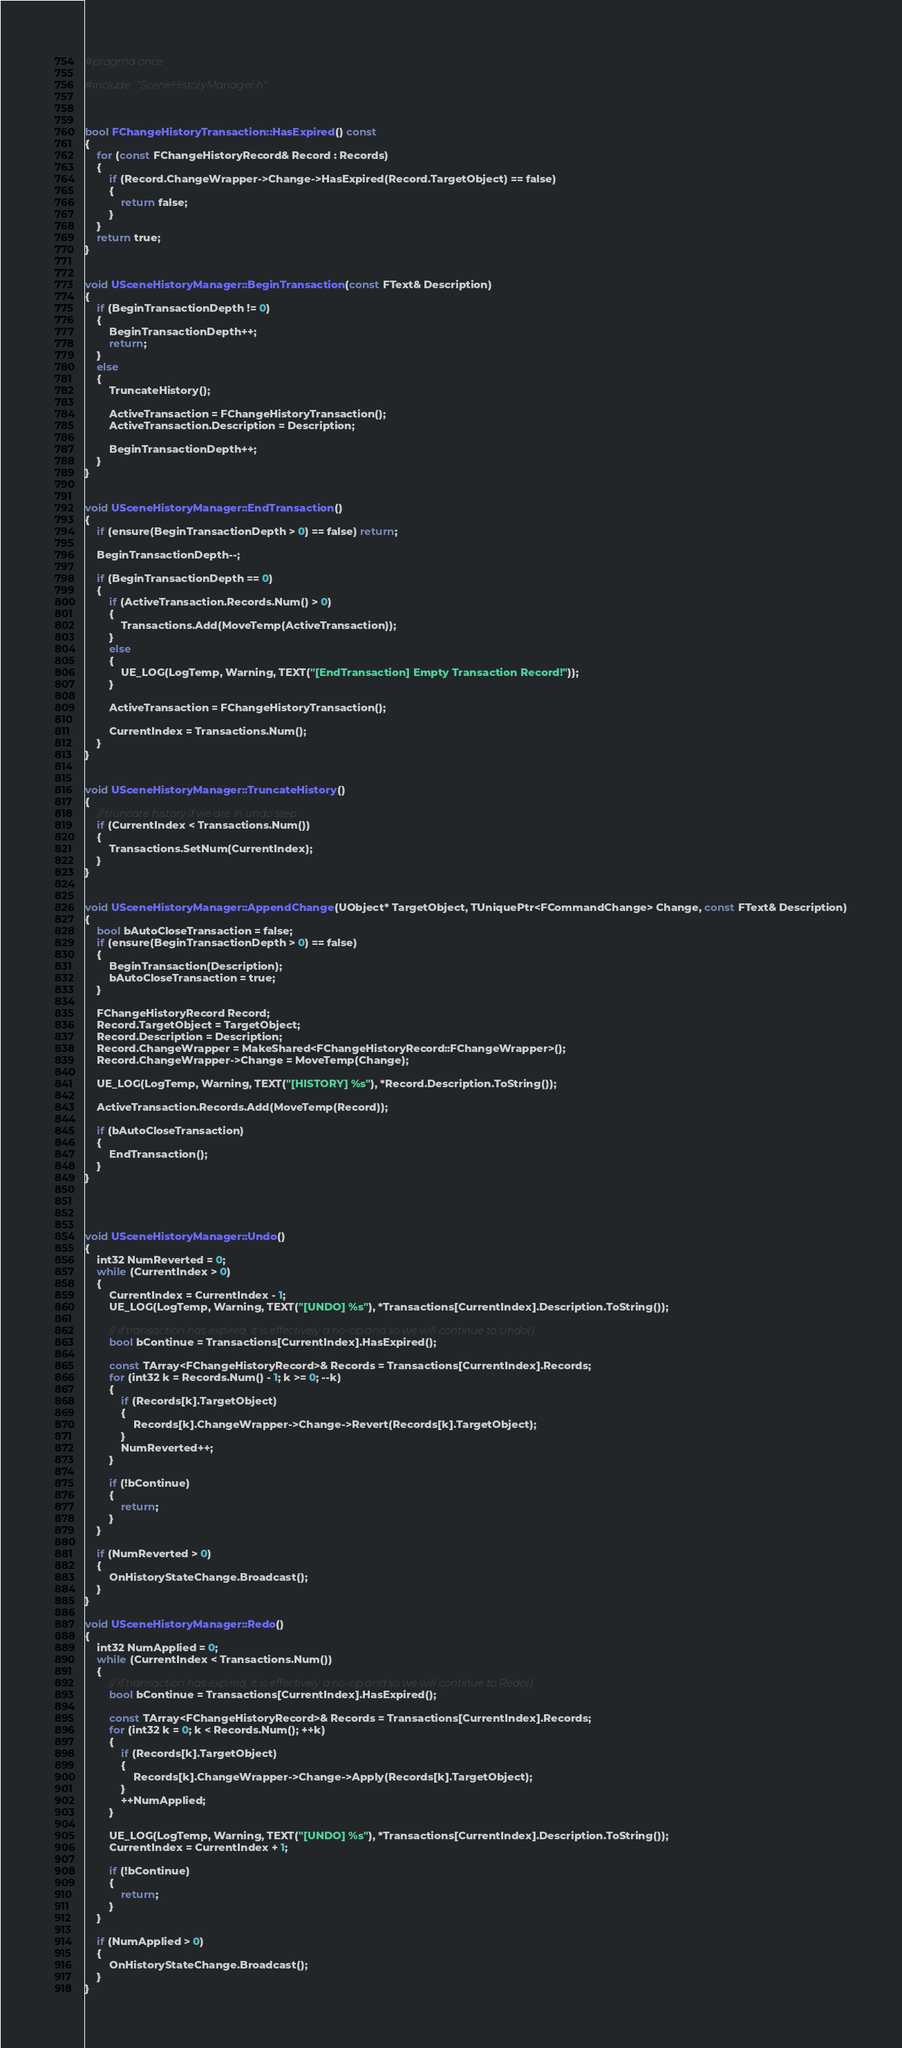Convert code to text. <code><loc_0><loc_0><loc_500><loc_500><_C++_>
#pragma once

#include "SceneHistoryManager.h"



bool FChangeHistoryTransaction::HasExpired() const
{
	for (const FChangeHistoryRecord& Record : Records)
	{
		if (Record.ChangeWrapper->Change->HasExpired(Record.TargetObject) == false)
		{
			return false;
		}
	}
	return true;
}


void USceneHistoryManager::BeginTransaction(const FText& Description)
{
	if (BeginTransactionDepth != 0)
	{
		BeginTransactionDepth++;
		return;
	}
	else
	{
		TruncateHistory();

		ActiveTransaction = FChangeHistoryTransaction();
		ActiveTransaction.Description = Description;

		BeginTransactionDepth++;
	}
}


void USceneHistoryManager::EndTransaction()
{
	if (ensure(BeginTransactionDepth > 0) == false) return;

	BeginTransactionDepth--;

	if (BeginTransactionDepth == 0)
	{
		if (ActiveTransaction.Records.Num() > 0)
		{
			Transactions.Add(MoveTemp(ActiveTransaction));
		}
		else
		{
			UE_LOG(LogTemp, Warning, TEXT("[EndTransaction] Empty Transaction Record!"));
		}

		ActiveTransaction = FChangeHistoryTransaction();

		CurrentIndex = Transactions.Num();
	}
}


void USceneHistoryManager::TruncateHistory()
{
	// truncate history if we are in undo step
	if (CurrentIndex < Transactions.Num())
	{
		Transactions.SetNum(CurrentIndex);
	}
}


void USceneHistoryManager::AppendChange(UObject* TargetObject, TUniquePtr<FCommandChange> Change, const FText& Description)
{
	bool bAutoCloseTransaction = false;
	if (ensure(BeginTransactionDepth > 0) == false)
	{
		BeginTransaction(Description);
		bAutoCloseTransaction = true;
	}

	FChangeHistoryRecord Record;
	Record.TargetObject = TargetObject;
	Record.Description = Description;
	Record.ChangeWrapper = MakeShared<FChangeHistoryRecord::FChangeWrapper>();
	Record.ChangeWrapper->Change = MoveTemp(Change);

	UE_LOG(LogTemp, Warning, TEXT("[HISTORY] %s"), *Record.Description.ToString());

	ActiveTransaction.Records.Add(MoveTemp(Record));

	if (bAutoCloseTransaction)
	{
		EndTransaction();
	}
}




void USceneHistoryManager::Undo()
{
	int32 NumReverted = 0;
	while (CurrentIndex > 0)
	{
		CurrentIndex = CurrentIndex - 1;
		UE_LOG(LogTemp, Warning, TEXT("[UNDO] %s"), *Transactions[CurrentIndex].Description.ToString());

		// if transaction has expired, it is effectively a no-op and so we will continue to Undo()
		bool bContinue = Transactions[CurrentIndex].HasExpired();

		const TArray<FChangeHistoryRecord>& Records = Transactions[CurrentIndex].Records;
		for (int32 k = Records.Num() - 1; k >= 0; --k)
		{
			if (Records[k].TargetObject)
			{
				Records[k].ChangeWrapper->Change->Revert(Records[k].TargetObject);
			}
			NumReverted++;
		}

		if (!bContinue)
		{
			return;
		}
	}

	if (NumReverted > 0)
	{
		OnHistoryStateChange.Broadcast();
	}
}

void USceneHistoryManager::Redo()
{
	int32 NumApplied = 0;
	while (CurrentIndex < Transactions.Num())
	{
		// if transaction has expired, it is effectively a no-op and so we will continue to Redo()
		bool bContinue = Transactions[CurrentIndex].HasExpired();

		const TArray<FChangeHistoryRecord>& Records = Transactions[CurrentIndex].Records;
		for (int32 k = 0; k < Records.Num(); ++k)
		{
			if (Records[k].TargetObject)
			{
				Records[k].ChangeWrapper->Change->Apply(Records[k].TargetObject);
			}
			++NumApplied;
		}

		UE_LOG(LogTemp, Warning, TEXT("[UNDO] %s"), *Transactions[CurrentIndex].Description.ToString());
		CurrentIndex = CurrentIndex + 1;

		if (!bContinue)
		{
			return;
		}
	}

	if (NumApplied > 0)
	{
		OnHistoryStateChange.Broadcast();
	}
}
</code> 